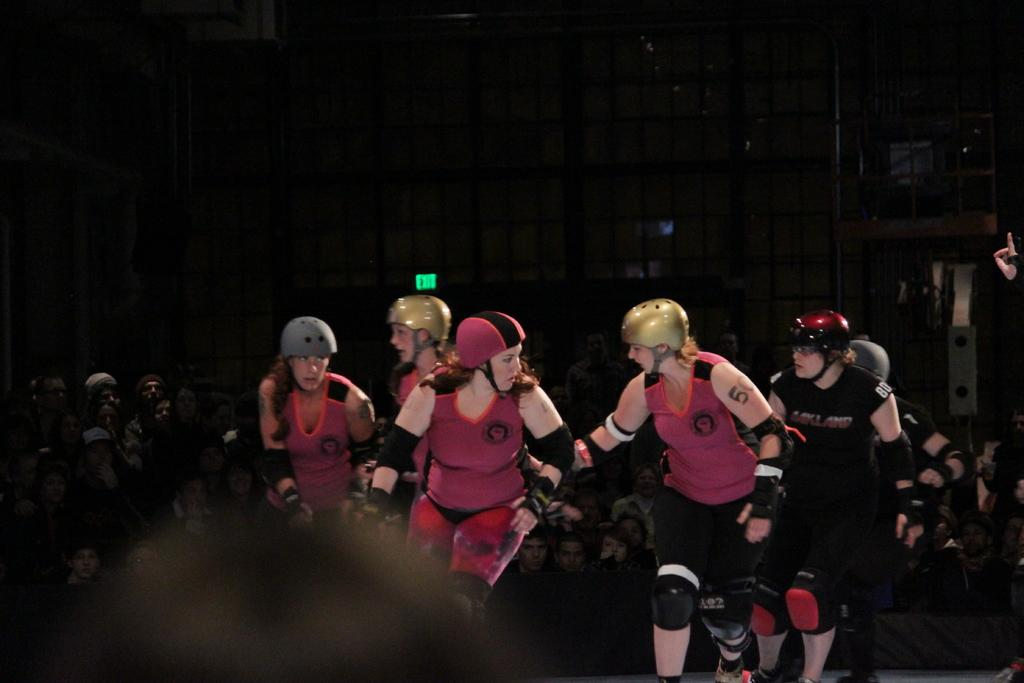What activity are the sports people engaged in within the image? The sports people are playing a game in the image. Can you describe the environment in which the game is taking place? There is a crowd sitting in the background of the image, which suggests that the game is being played in a public or spectator-friendly setting. What else can be seen in the background of the image? There is a building visible in the background of the image. How many stitches are visible on the sports people's uniforms in the image? There is no information about the stitches on the sports people's uniforms in the image, so it cannot be determined. 